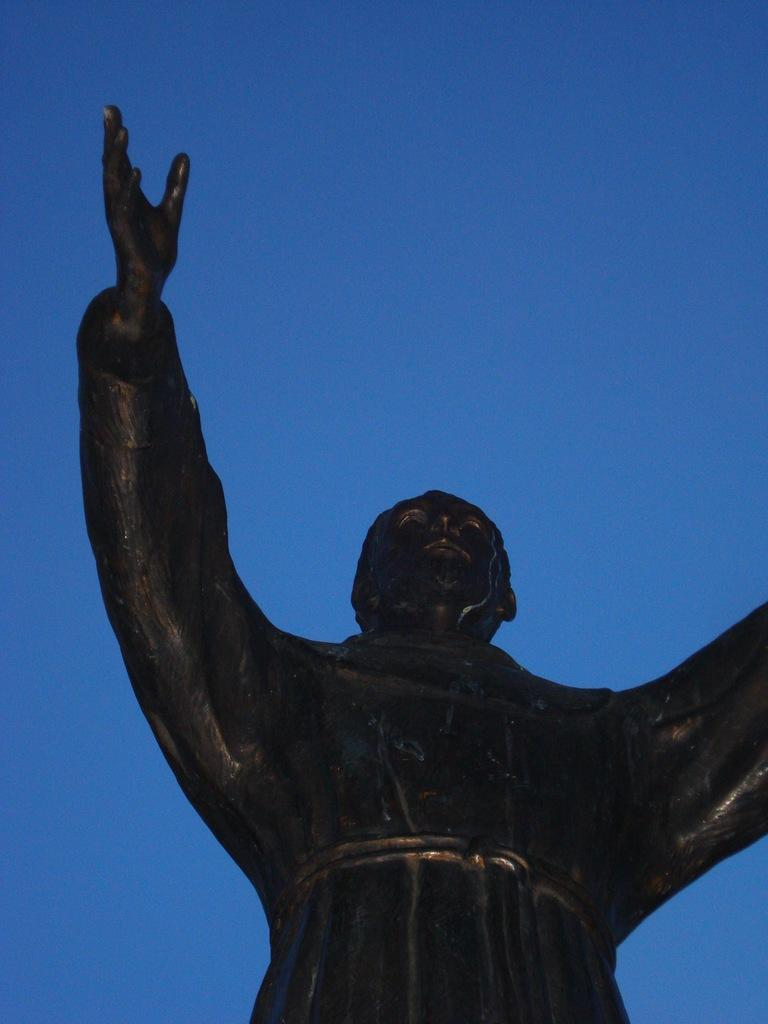What is the main subject in the image? There is a statue in the image. What can be seen in the background of the image? The sky is visible in the background of the image. What type of meal is being prepared in the image? A: There is no meal preparation visible in the image; it only features a statue and the sky in the background. 